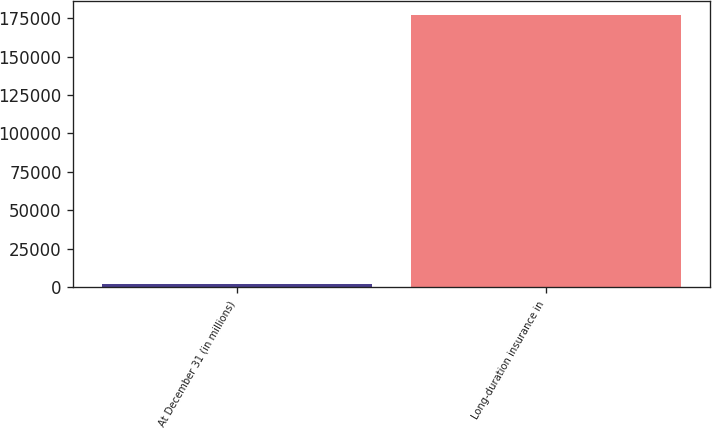Convert chart. <chart><loc_0><loc_0><loc_500><loc_500><bar_chart><fcel>At December 31 (in millions)<fcel>Long-duration insurance in<nl><fcel>2015<fcel>177025<nl></chart> 